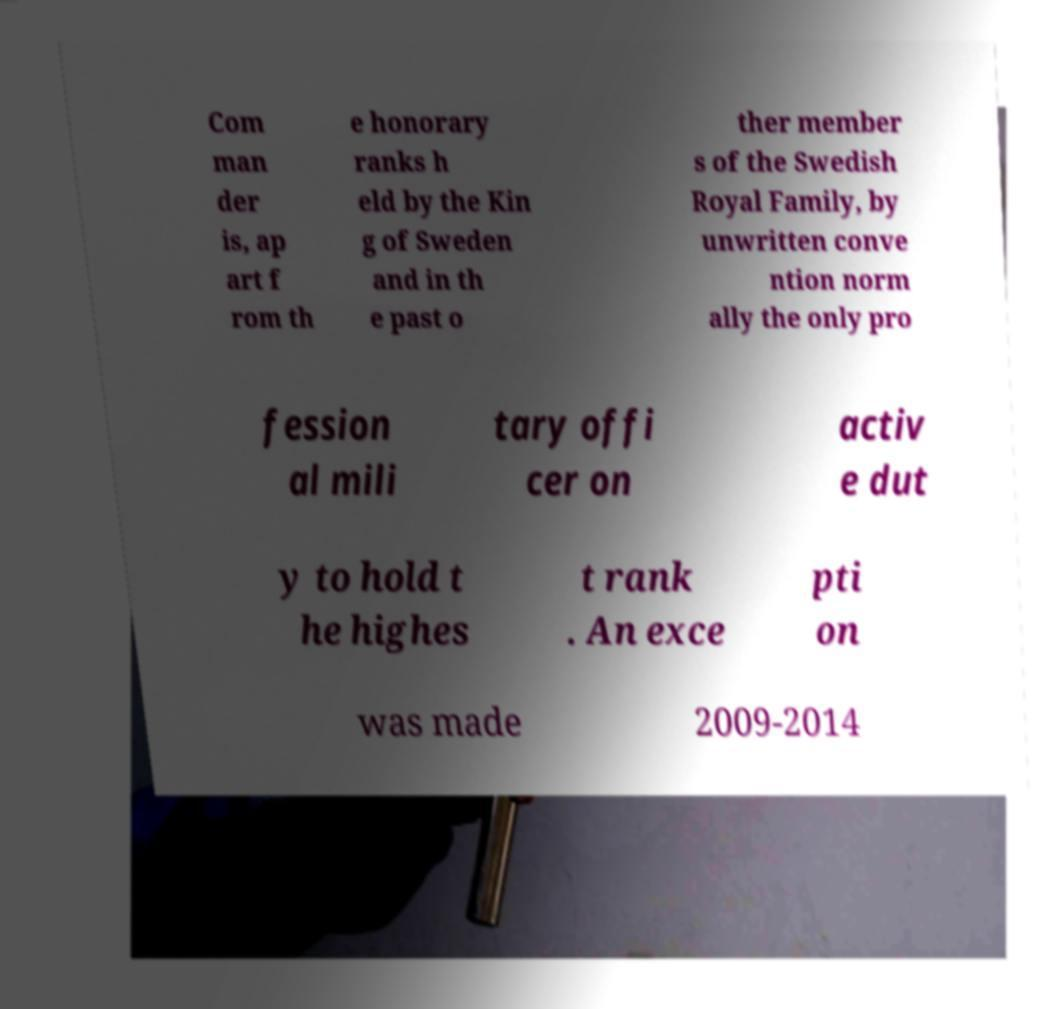For documentation purposes, I need the text within this image transcribed. Could you provide that? Com man der is, ap art f rom th e honorary ranks h eld by the Kin g of Sweden and in th e past o ther member s of the Swedish Royal Family, by unwritten conve ntion norm ally the only pro fession al mili tary offi cer on activ e dut y to hold t he highes t rank . An exce pti on was made 2009-2014 